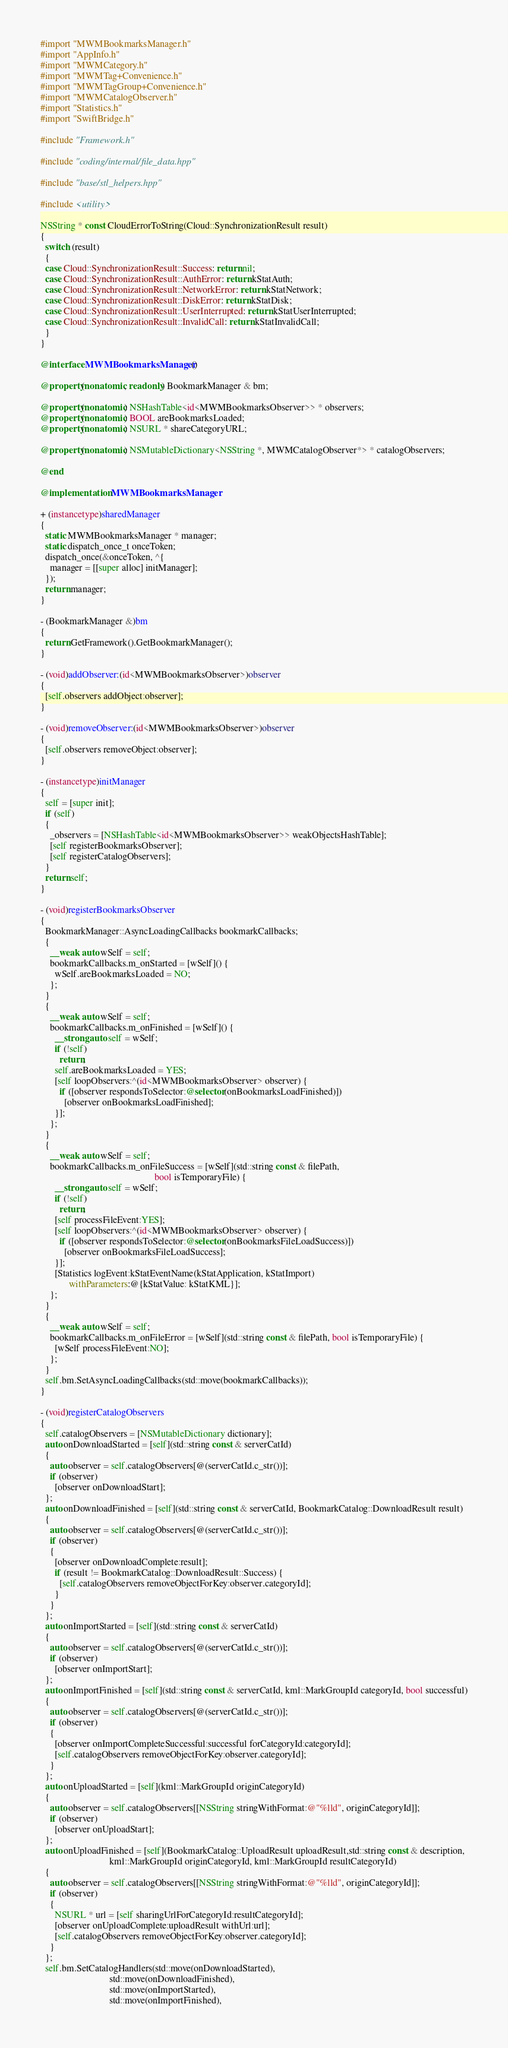<code> <loc_0><loc_0><loc_500><loc_500><_ObjectiveC_>#import "MWMBookmarksManager.h"
#import "AppInfo.h"
#import "MWMCategory.h"
#import "MWMTag+Convenience.h"
#import "MWMTagGroup+Convenience.h"
#import "MWMCatalogObserver.h"
#import "Statistics.h"
#import "SwiftBridge.h"

#include "Framework.h"

#include "coding/internal/file_data.hpp"

#include "base/stl_helpers.hpp"

#include <utility>

NSString * const CloudErrorToString(Cloud::SynchronizationResult result)
{
  switch (result)
  {
  case Cloud::SynchronizationResult::Success: return nil;
  case Cloud::SynchronizationResult::AuthError: return kStatAuth;
  case Cloud::SynchronizationResult::NetworkError: return kStatNetwork;
  case Cloud::SynchronizationResult::DiskError: return kStatDisk;
  case Cloud::SynchronizationResult::UserInterrupted: return kStatUserInterrupted;
  case Cloud::SynchronizationResult::InvalidCall: return kStatInvalidCall;
  }
}

@interface MWMBookmarksManager ()

@property(nonatomic, readonly) BookmarkManager & bm;

@property(nonatomic) NSHashTable<id<MWMBookmarksObserver>> * observers;
@property(nonatomic) BOOL areBookmarksLoaded;
@property(nonatomic) NSURL * shareCategoryURL;

@property(nonatomic) NSMutableDictionary<NSString *, MWMCatalogObserver*> * catalogObservers;

@end

@implementation MWMBookmarksManager

+ (instancetype)sharedManager
{
  static MWMBookmarksManager * manager;
  static dispatch_once_t onceToken;
  dispatch_once(&onceToken, ^{
    manager = [[super alloc] initManager];
  });
  return manager;
}

- (BookmarkManager &)bm
{
  return GetFramework().GetBookmarkManager();
}

- (void)addObserver:(id<MWMBookmarksObserver>)observer
{
  [self.observers addObject:observer];
}

- (void)removeObserver:(id<MWMBookmarksObserver>)observer
{
  [self.observers removeObject:observer];
}

- (instancetype)initManager
{
  self = [super init];
  if (self)
  {
    _observers = [NSHashTable<id<MWMBookmarksObserver>> weakObjectsHashTable];
    [self registerBookmarksObserver];
    [self registerCatalogObservers];
  }
  return self;
}

- (void)registerBookmarksObserver
{
  BookmarkManager::AsyncLoadingCallbacks bookmarkCallbacks;
  {
    __weak auto wSelf = self;
    bookmarkCallbacks.m_onStarted = [wSelf]() {
      wSelf.areBookmarksLoaded = NO;
    };
  }
  {
    __weak auto wSelf = self;
    bookmarkCallbacks.m_onFinished = [wSelf]() {
      __strong auto self = wSelf;
      if (!self)
        return;
      self.areBookmarksLoaded = YES;
      [self loopObservers:^(id<MWMBookmarksObserver> observer) {
        if ([observer respondsToSelector:@selector(onBookmarksLoadFinished)])
          [observer onBookmarksLoadFinished];
      }];
    };
  }
  {
    __weak auto wSelf = self;
    bookmarkCallbacks.m_onFileSuccess = [wSelf](std::string const & filePath,
                                                bool isTemporaryFile) {
      __strong auto self = wSelf;
      if (!self)
        return;
      [self processFileEvent:YES];
      [self loopObservers:^(id<MWMBookmarksObserver> observer) {
        if ([observer respondsToSelector:@selector(onBookmarksFileLoadSuccess)])
          [observer onBookmarksFileLoadSuccess];
      }];
      [Statistics logEvent:kStatEventName(kStatApplication, kStatImport)
            withParameters:@{kStatValue: kStatKML}];
    };
  }
  {
    __weak auto wSelf = self;
    bookmarkCallbacks.m_onFileError = [wSelf](std::string const & filePath, bool isTemporaryFile) {
      [wSelf processFileEvent:NO];
    };
  }
  self.bm.SetAsyncLoadingCallbacks(std::move(bookmarkCallbacks));
}

- (void)registerCatalogObservers
{
  self.catalogObservers = [NSMutableDictionary dictionary];
  auto onDownloadStarted = [self](std::string const & serverCatId)
  {
    auto observer = self.catalogObservers[@(serverCatId.c_str())];
    if (observer)
      [observer onDownloadStart];
  };
  auto onDownloadFinished = [self](std::string const & serverCatId, BookmarkCatalog::DownloadResult result)
  {
    auto observer = self.catalogObservers[@(serverCatId.c_str())];
    if (observer)
    {
      [observer onDownloadComplete:result];
      if (result != BookmarkCatalog::DownloadResult::Success) {
        [self.catalogObservers removeObjectForKey:observer.categoryId];
      }
    }
  };
  auto onImportStarted = [self](std::string const & serverCatId)
  {
    auto observer = self.catalogObservers[@(serverCatId.c_str())];
    if (observer)
      [observer onImportStart];
  };
  auto onImportFinished = [self](std::string const & serverCatId, kml::MarkGroupId categoryId, bool successful)
  {
    auto observer = self.catalogObservers[@(serverCatId.c_str())];
    if (observer)
    {
      [observer onImportCompleteSuccessful:successful forCategoryId:categoryId];
      [self.catalogObservers removeObjectForKey:observer.categoryId];
    }
  };
  auto onUploadStarted = [self](kml::MarkGroupId originCategoryId)
  {
    auto observer = self.catalogObservers[[NSString stringWithFormat:@"%lld", originCategoryId]];
    if (observer)
      [observer onUploadStart];
  };
  auto onUploadFinished = [self](BookmarkCatalog::UploadResult uploadResult,std::string const & description,
                             kml::MarkGroupId originCategoryId, kml::MarkGroupId resultCategoryId)
  {
    auto observer = self.catalogObservers[[NSString stringWithFormat:@"%lld", originCategoryId]];
    if (observer)
    {
      NSURL * url = [self sharingUrlForCategoryId:resultCategoryId];
      [observer onUploadComplete:uploadResult withUrl:url];
      [self.catalogObservers removeObjectForKey:observer.categoryId];
    }
  };
  self.bm.SetCatalogHandlers(std::move(onDownloadStarted),
                             std::move(onDownloadFinished),
                             std::move(onImportStarted),
                             std::move(onImportFinished),</code> 